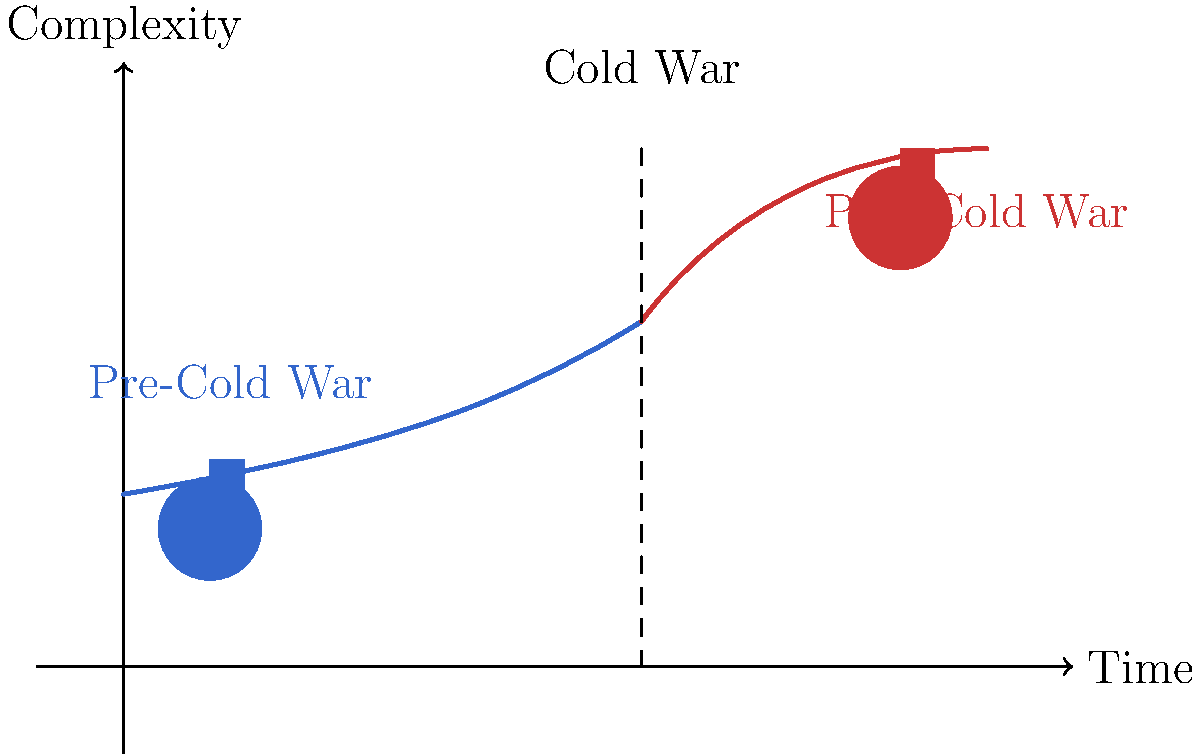Based on your experience in Hollywood, how did the complexity of hero archetypes in films evolve from the pre-Cold War era to the post-Cold War period, as illustrated by the graph? 1. Pre-Cold War era (left side of the graph):
   - The curve starts lower on the complexity axis.
   - Hero archetypes were typically simpler, more straightforward.
   - Characters often embodied clear-cut moral values and patriotic ideals.

2. During the Cold War:
   - The vertical dashed line represents the Cold War period.
   - This era saw a gradual increase in character complexity.
   - Heroes began to show more nuanced traits, reflecting geopolitical tensions.

3. Post-Cold War era (right side of the graph):
   - The curve rises more steeply, indicating a significant increase in complexity.
   - Hero archetypes became more morally ambiguous and psychologically complex.
   - Characters often grappled with internal conflicts and ethical dilemmas.

4. Visual representation:
   - The blue silhouette (left) represents the simpler pre-Cold War hero.
   - The red silhouette (right) symbolizes the more complex post-Cold War hero.
   - The change in size and color emphasizes the transformation in character depth.

5. Overall trend:
   - The graph shows a clear progression from simpler to more complex hero archetypes.
   - This shift reflects changing societal values and a more nuanced understanding of heroism.
   - The end of the Cold War allowed for more diverse and morally ambiguous characters in Hollywood films.
Answer: Increased significantly 